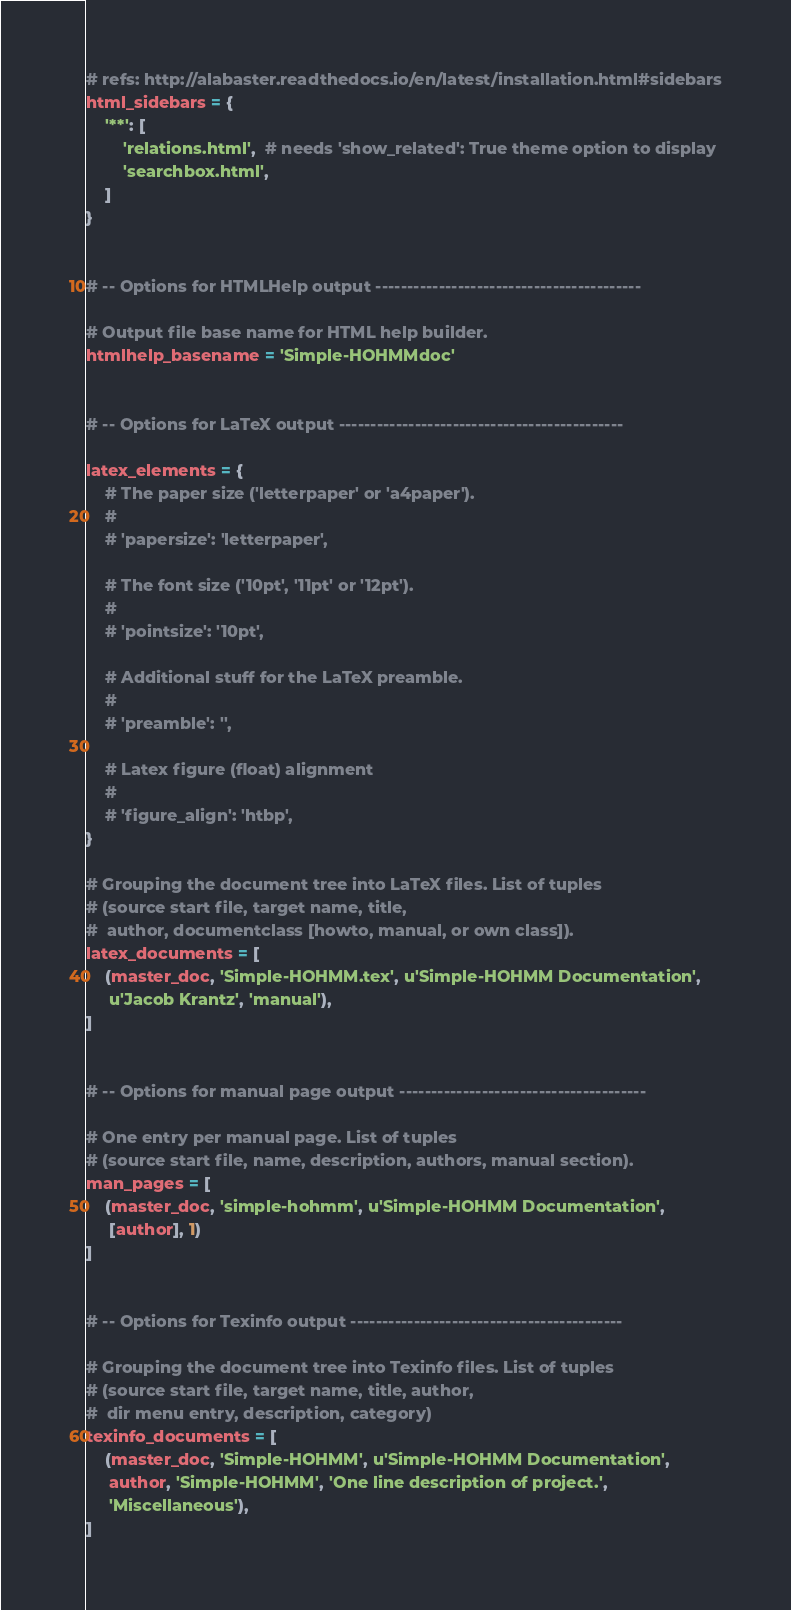Convert code to text. <code><loc_0><loc_0><loc_500><loc_500><_Python_># refs: http://alabaster.readthedocs.io/en/latest/installation.html#sidebars
html_sidebars = {
    '**': [
        'relations.html',  # needs 'show_related': True theme option to display
        'searchbox.html',
    ]
}


# -- Options for HTMLHelp output ------------------------------------------

# Output file base name for HTML help builder.
htmlhelp_basename = 'Simple-HOHMMdoc'


# -- Options for LaTeX output ---------------------------------------------

latex_elements = {
    # The paper size ('letterpaper' or 'a4paper').
    #
    # 'papersize': 'letterpaper',

    # The font size ('10pt', '11pt' or '12pt').
    #
    # 'pointsize': '10pt',

    # Additional stuff for the LaTeX preamble.
    #
    # 'preamble': '',

    # Latex figure (float) alignment
    #
    # 'figure_align': 'htbp',
}

# Grouping the document tree into LaTeX files. List of tuples
# (source start file, target name, title,
#  author, documentclass [howto, manual, or own class]).
latex_documents = [
    (master_doc, 'Simple-HOHMM.tex', u'Simple-HOHMM Documentation',
     u'Jacob Krantz', 'manual'),
]


# -- Options for manual page output ---------------------------------------

# One entry per manual page. List of tuples
# (source start file, name, description, authors, manual section).
man_pages = [
    (master_doc, 'simple-hohmm', u'Simple-HOHMM Documentation',
     [author], 1)
]


# -- Options for Texinfo output -------------------------------------------

# Grouping the document tree into Texinfo files. List of tuples
# (source start file, target name, title, author,
#  dir menu entry, description, category)
texinfo_documents = [
    (master_doc, 'Simple-HOHMM', u'Simple-HOHMM Documentation',
     author, 'Simple-HOHMM', 'One line description of project.',
     'Miscellaneous'),
]
</code> 